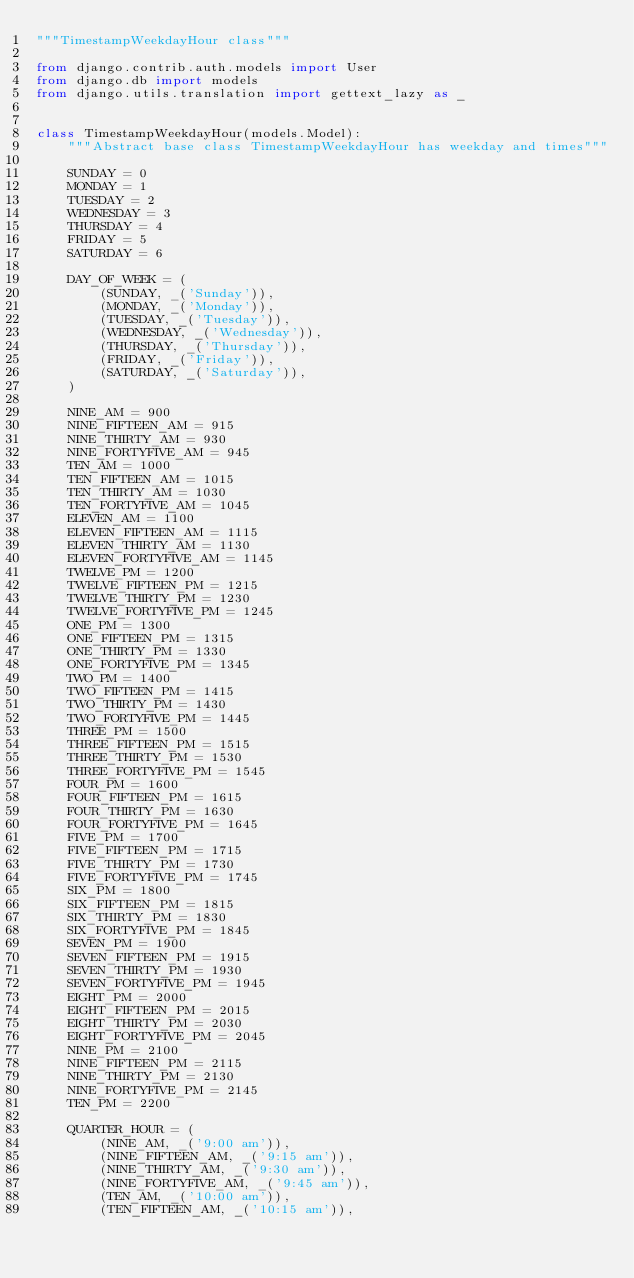Convert code to text. <code><loc_0><loc_0><loc_500><loc_500><_Python_>"""TimestampWeekdayHour class"""

from django.contrib.auth.models import User
from django.db import models
from django.utils.translation import gettext_lazy as _


class TimestampWeekdayHour(models.Model):
    """Abstract base class TimestampWeekdayHour has weekday and times"""

    SUNDAY = 0
    MONDAY = 1
    TUESDAY = 2
    WEDNESDAY = 3
    THURSDAY = 4
    FRIDAY = 5
    SATURDAY = 6

    DAY_OF_WEEK = (
        (SUNDAY, _('Sunday')),
        (MONDAY, _('Monday')),
        (TUESDAY, _('Tuesday')),
        (WEDNESDAY, _('Wednesday')),
        (THURSDAY, _('Thursday')),
        (FRIDAY, _('Friday')),
        (SATURDAY, _('Saturday')),
    )

    NINE_AM = 900
    NINE_FIFTEEN_AM = 915
    NINE_THIRTY_AM = 930
    NINE_FORTYFIVE_AM = 945
    TEN_AM = 1000
    TEN_FIFTEEN_AM = 1015
    TEN_THIRTY_AM = 1030
    TEN_FORTYFIVE_AM = 1045
    ELEVEN_AM = 1100
    ELEVEN_FIFTEEN_AM = 1115
    ELEVEN_THIRTY_AM = 1130
    ELEVEN_FORTYFIVE_AM = 1145
    TWELVE_PM = 1200
    TWELVE_FIFTEEN_PM = 1215
    TWELVE_THIRTY_PM = 1230
    TWELVE_FORTYFIVE_PM = 1245
    ONE_PM = 1300
    ONE_FIFTEEN_PM = 1315
    ONE_THIRTY_PM = 1330
    ONE_FORTYFIVE_PM = 1345
    TWO_PM = 1400
    TWO_FIFTEEN_PM = 1415
    TWO_THIRTY_PM = 1430
    TWO_FORTYFIVE_PM = 1445
    THREE_PM = 1500
    THREE_FIFTEEN_PM = 1515
    THREE_THIRTY_PM = 1530
    THREE_FORTYFIVE_PM = 1545
    FOUR_PM = 1600
    FOUR_FIFTEEN_PM = 1615
    FOUR_THIRTY_PM = 1630
    FOUR_FORTYFIVE_PM = 1645
    FIVE_PM = 1700
    FIVE_FIFTEEN_PM = 1715
    FIVE_THIRTY_PM = 1730
    FIVE_FORTYFIVE_PM = 1745
    SIX_PM = 1800
    SIX_FIFTEEN_PM = 1815
    SIX_THIRTY_PM = 1830
    SIX_FORTYFIVE_PM = 1845
    SEVEN_PM = 1900
    SEVEN_FIFTEEN_PM = 1915
    SEVEN_THIRTY_PM = 1930
    SEVEN_FORTYFIVE_PM = 1945
    EIGHT_PM = 2000
    EIGHT_FIFTEEN_PM = 2015
    EIGHT_THIRTY_PM = 2030
    EIGHT_FORTYFIVE_PM = 2045
    NINE_PM = 2100
    NINE_FIFTEEN_PM = 2115
    NINE_THIRTY_PM = 2130
    NINE_FORTYFIVE_PM = 2145
    TEN_PM = 2200

    QUARTER_HOUR = (
        (NINE_AM, _('9:00 am')),
        (NINE_FIFTEEN_AM, _('9:15 am')),
        (NINE_THIRTY_AM, _('9:30 am')),
        (NINE_FORTYFIVE_AM, _('9:45 am')),
        (TEN_AM, _('10:00 am')),
        (TEN_FIFTEEN_AM, _('10:15 am')),</code> 